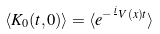Convert formula to latex. <formula><loc_0><loc_0><loc_500><loc_500>\langle K _ { 0 } ( t , 0 ) \rangle = \langle e ^ { - \frac { i } { } V ( { x } ) t } \rangle</formula> 